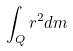<formula> <loc_0><loc_0><loc_500><loc_500>\int _ { Q } r ^ { 2 } d m</formula> 